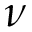Convert formula to latex. <formula><loc_0><loc_0><loc_500><loc_500>\nu</formula> 